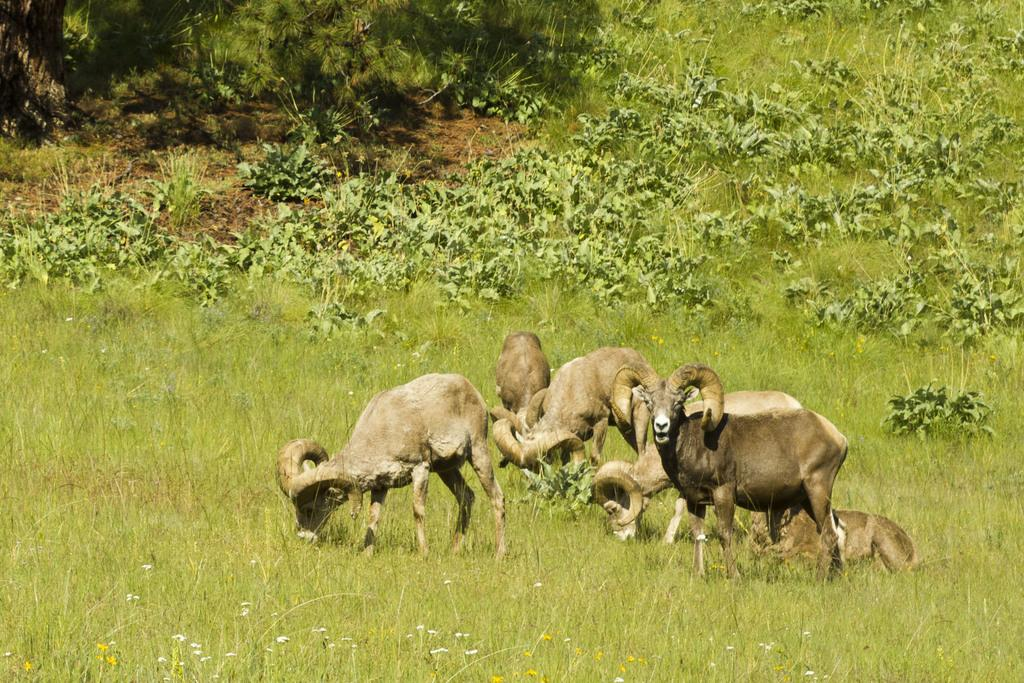What type of animals are standing on the ground in the image? There are bighorn sheep standing on the ground in the image. What is the position of the other animal in the image? There is an animal sitting on the grass in the image. What can be seen in the background of the image? Plants are visible in the background of the image. What type of feast is being prepared in the image? There is no indication of a feast being prepared in the image; it features bighorn sheep and an animal sitting on the grass. What scientific discovery is being made in the image? There is no scientific discovery being made in the image; it is a simple scene of animals in a natural setting. 